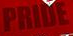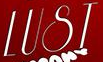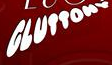Read the text content from these images in order, separated by a semicolon. PRIDE; LUST; GLUTTONV 